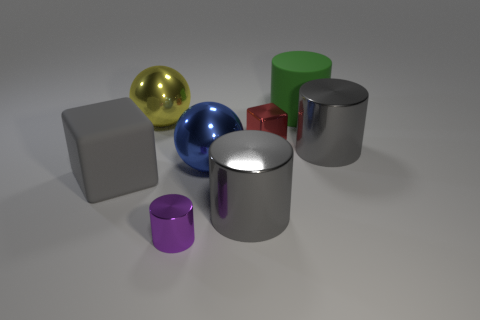There is a gray cylinder that is right of the gray metallic cylinder in front of the rubber block; how big is it?
Give a very brief answer. Large. What number of small objects are gray blocks or blue shiny cylinders?
Give a very brief answer. 0. Are there fewer tiny red blocks than small red cylinders?
Offer a terse response. No. Is there anything else that has the same size as the red shiny block?
Ensure brevity in your answer.  Yes. Is the metallic cube the same color as the small cylinder?
Make the answer very short. No. Are there more purple things than large brown balls?
Offer a very short reply. Yes. What number of other objects are the same color as the big cube?
Give a very brief answer. 2. There is a small metal object that is to the left of the big blue metallic ball; what number of gray things are behind it?
Your answer should be very brief. 3. There is a small red object; are there any metal spheres behind it?
Offer a terse response. Yes. There is a tiny object to the left of the small object that is right of the small purple metallic cylinder; what is its shape?
Your answer should be very brief. Cylinder. 